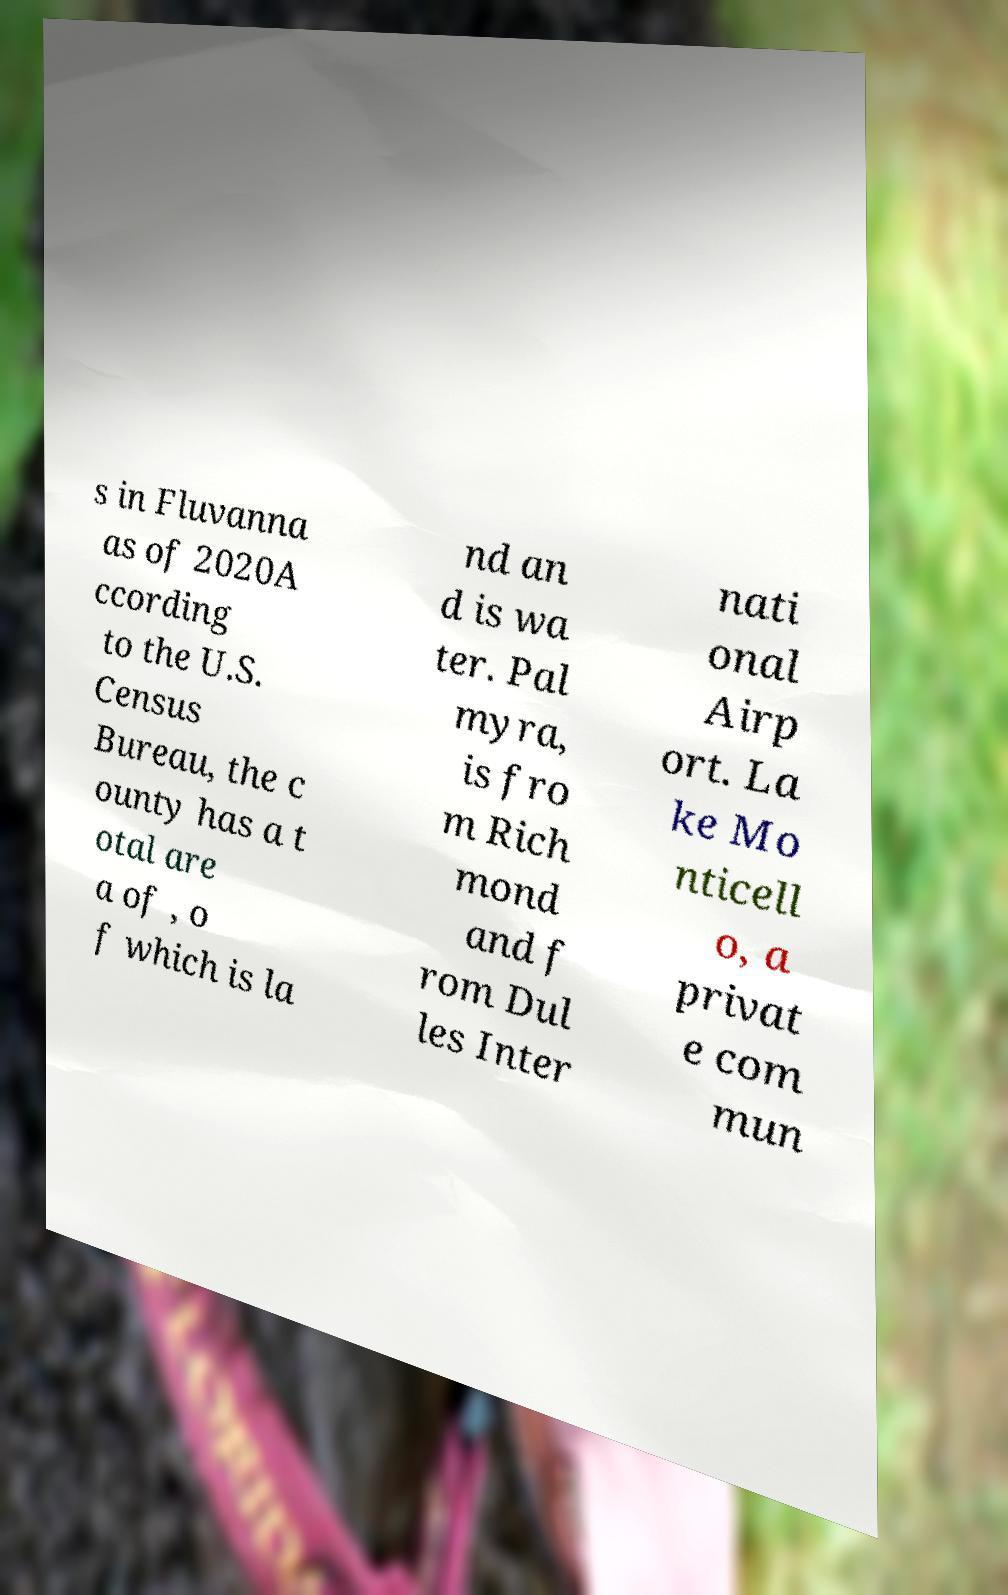Can you read and provide the text displayed in the image?This photo seems to have some interesting text. Can you extract and type it out for me? s in Fluvanna as of 2020A ccording to the U.S. Census Bureau, the c ounty has a t otal are a of , o f which is la nd an d is wa ter. Pal myra, is fro m Rich mond and f rom Dul les Inter nati onal Airp ort. La ke Mo nticell o, a privat e com mun 